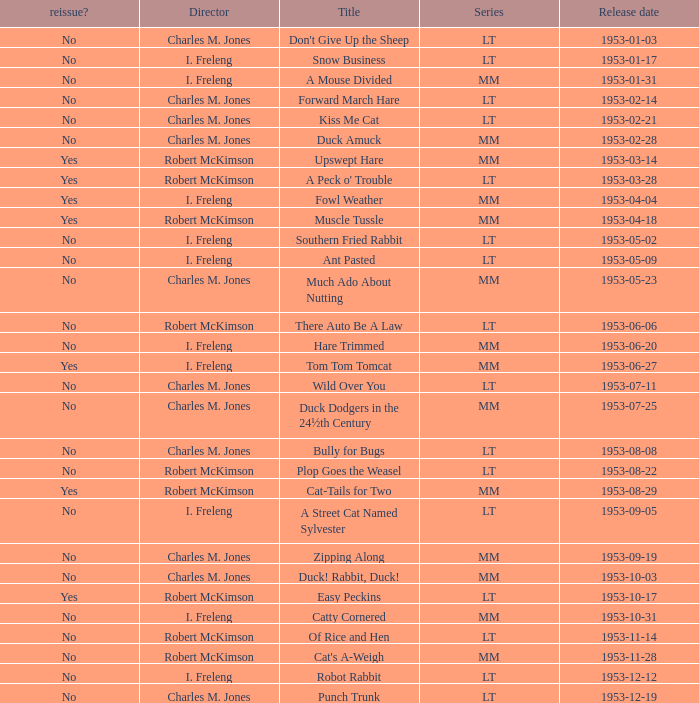What's the release date of Forward March Hare? 1953-02-14. 